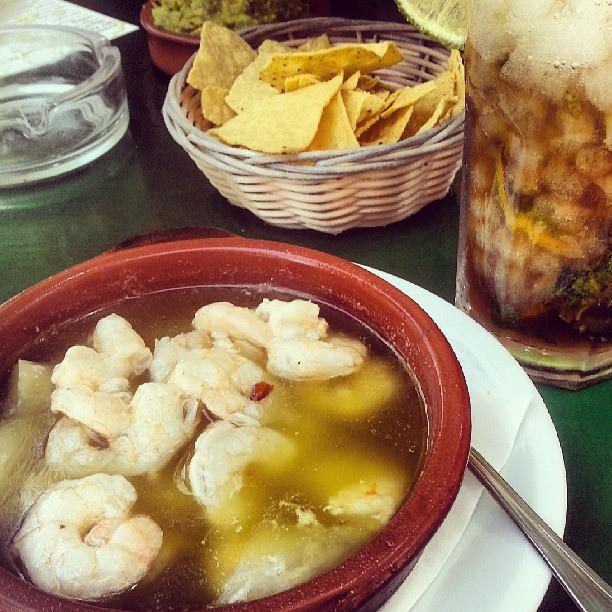Is the drink hot?
Concise answer only. No. What is in the bowl?
Answer briefly. Shrimp. Is there an ashtray on the table?
Give a very brief answer. Yes. 